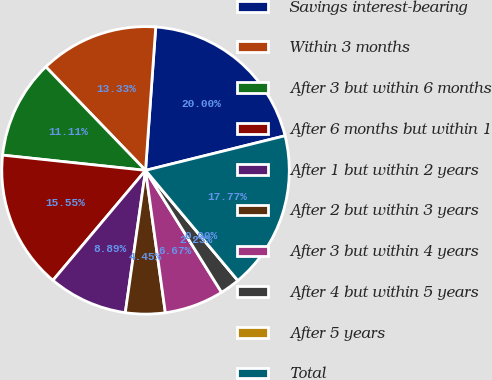Convert chart. <chart><loc_0><loc_0><loc_500><loc_500><pie_chart><fcel>Savings interest-bearing<fcel>Within 3 months<fcel>After 3 but within 6 months<fcel>After 6 months but within 1<fcel>After 1 but within 2 years<fcel>After 2 but within 3 years<fcel>After 3 but within 4 years<fcel>After 4 but within 5 years<fcel>After 5 years<fcel>Total<nl><fcel>20.0%<fcel>13.33%<fcel>11.11%<fcel>15.55%<fcel>8.89%<fcel>4.45%<fcel>6.67%<fcel>2.23%<fcel>0.0%<fcel>17.77%<nl></chart> 